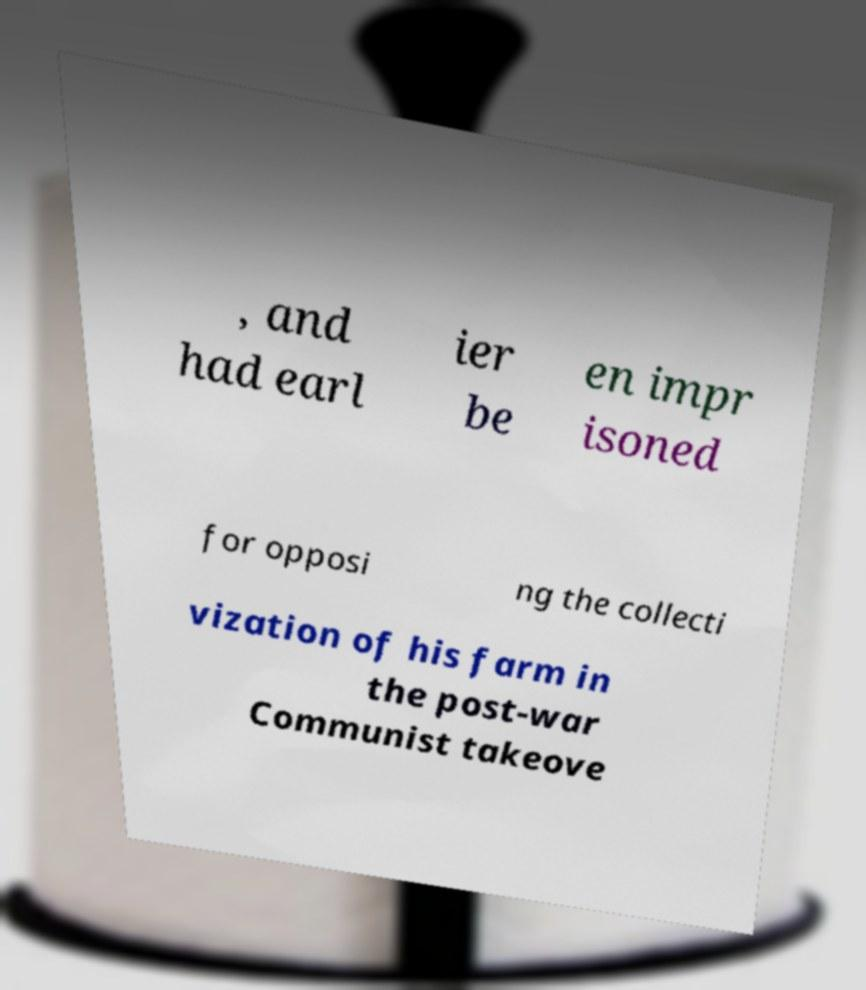I need the written content from this picture converted into text. Can you do that? , and had earl ier be en impr isoned for opposi ng the collecti vization of his farm in the post-war Communist takeove 